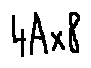Convert formula to latex. <formula><loc_0><loc_0><loc_500><loc_500>4 A \times 8</formula> 